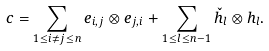<formula> <loc_0><loc_0><loc_500><loc_500>c = \sum _ { 1 \leq i \neq j \leq n } e _ { i , j } \otimes e _ { j , i } + \sum _ { 1 \leq l \leq n - 1 } \check { h } _ { l } \otimes h _ { l } .</formula> 